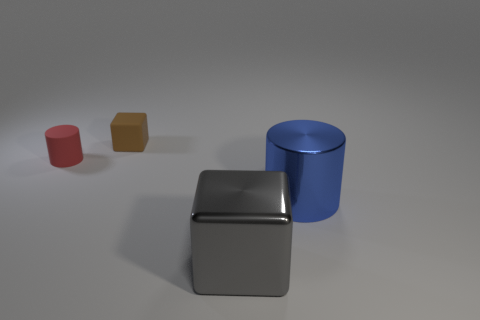Add 2 big purple shiny things. How many objects exist? 6 Subtract all blue cylinders. How many cylinders are left? 1 Subtract all green blocks. Subtract all purple balls. How many blocks are left? 2 Subtract all yellow cylinders. How many cyan blocks are left? 0 Subtract all rubber blocks. Subtract all tiny red cylinders. How many objects are left? 2 Add 1 large blue objects. How many large blue objects are left? 2 Add 2 big metallic cylinders. How many big metallic cylinders exist? 3 Subtract 0 gray balls. How many objects are left? 4 